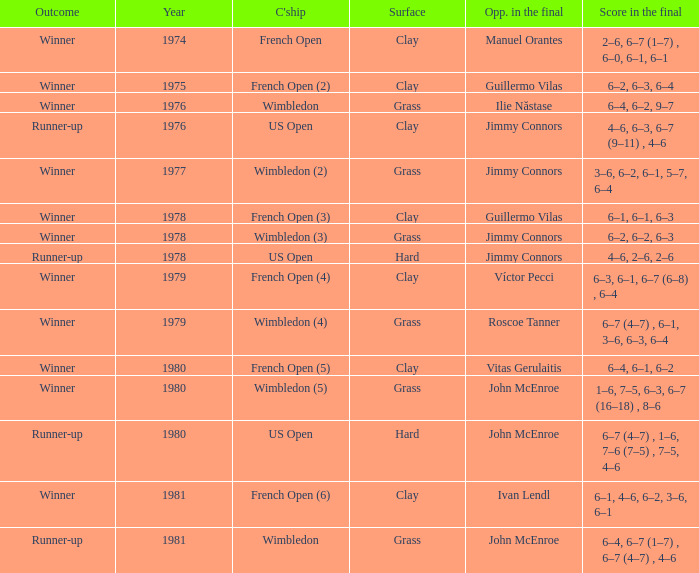What is every surface with a score in the final of 6–4, 6–7 (1–7) , 6–7 (4–7) , 4–6? Grass. 